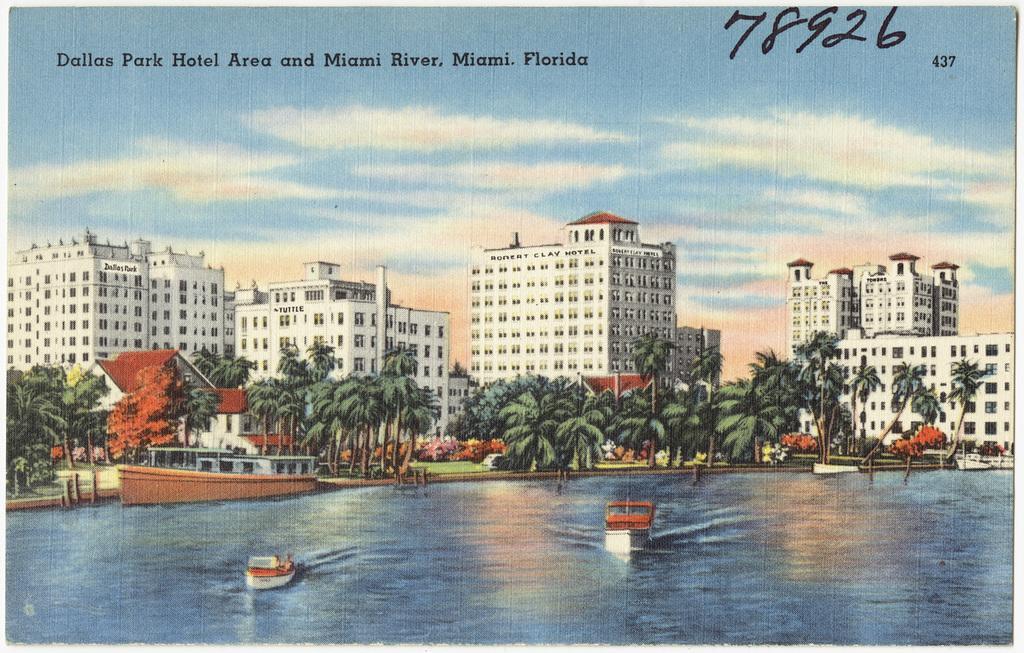Describe this image in one or two sentences. In this picture, it seems like a poster, where we can see buildings, trees, ships on the water surface and the sky. 